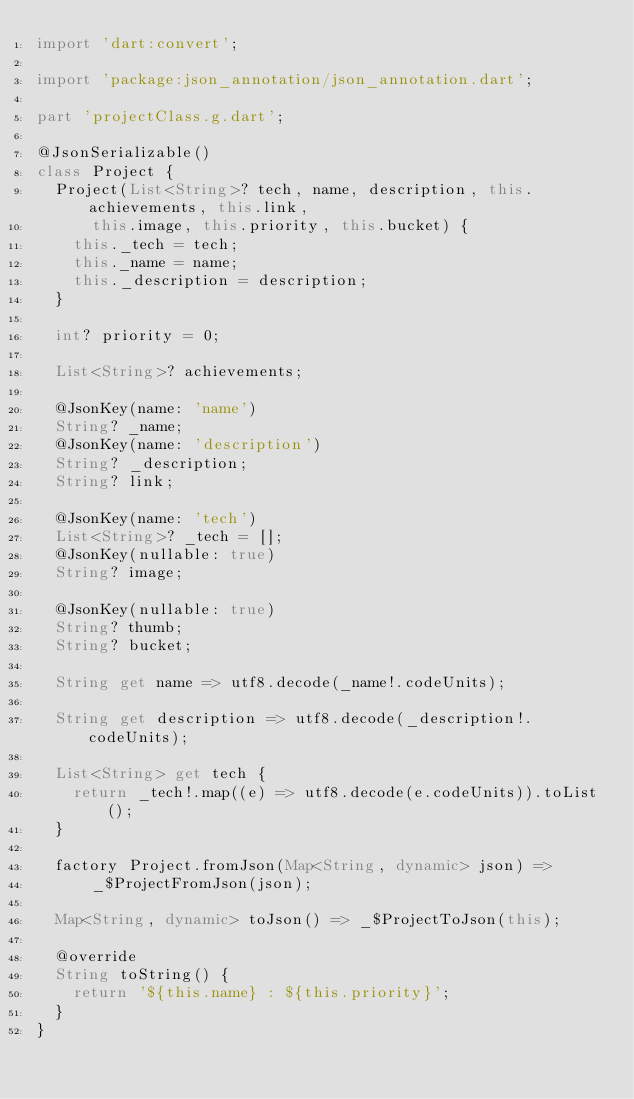<code> <loc_0><loc_0><loc_500><loc_500><_Dart_>import 'dart:convert';

import 'package:json_annotation/json_annotation.dart';

part 'projectClass.g.dart';

@JsonSerializable()
class Project {
  Project(List<String>? tech, name, description, this.achievements, this.link,
      this.image, this.priority, this.bucket) {
    this._tech = tech;
    this._name = name;
    this._description = description;
  }

  int? priority = 0;

  List<String>? achievements;

  @JsonKey(name: 'name')
  String? _name;
  @JsonKey(name: 'description')
  String? _description;
  String? link;

  @JsonKey(name: 'tech')
  List<String>? _tech = [];
  @JsonKey(nullable: true)
  String? image;

  @JsonKey(nullable: true)
  String? thumb;
  String? bucket;

  String get name => utf8.decode(_name!.codeUnits);

  String get description => utf8.decode(_description!.codeUnits);

  List<String> get tech {
    return _tech!.map((e) => utf8.decode(e.codeUnits)).toList();
  }

  factory Project.fromJson(Map<String, dynamic> json) =>
      _$ProjectFromJson(json);

  Map<String, dynamic> toJson() => _$ProjectToJson(this);

  @override
  String toString() {
    return '${this.name} : ${this.priority}';
  }
}
</code> 